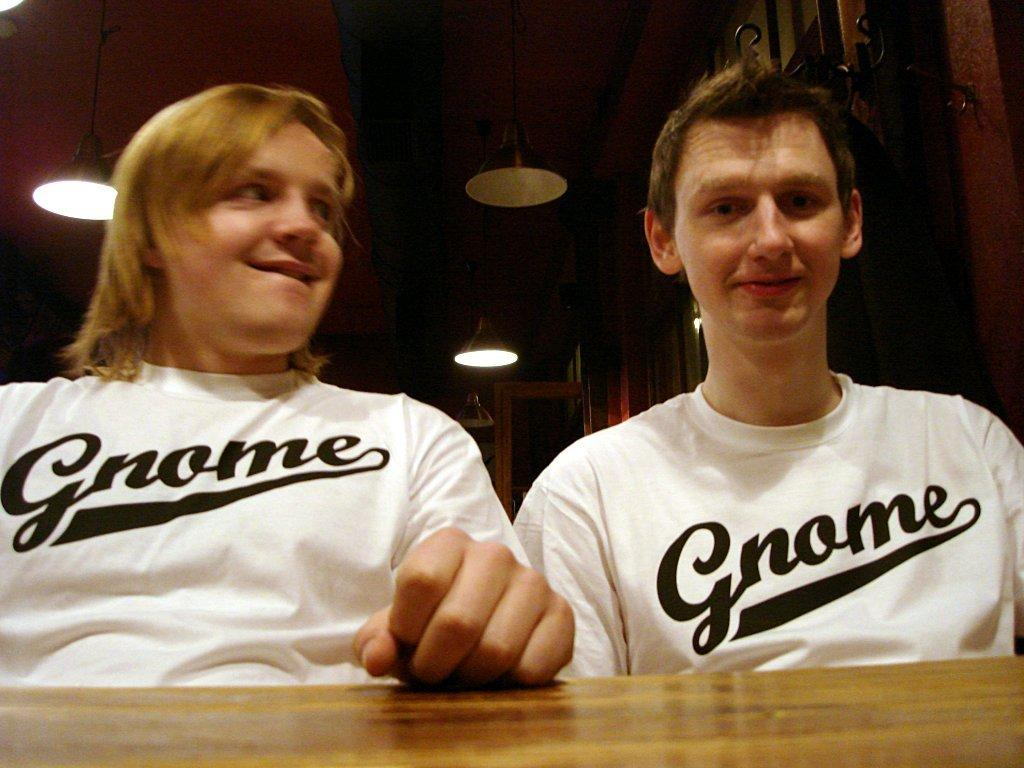<image>
Write a terse but informative summary of the picture. Two men, both wearing white tee shirts with the word Gnome on them. 